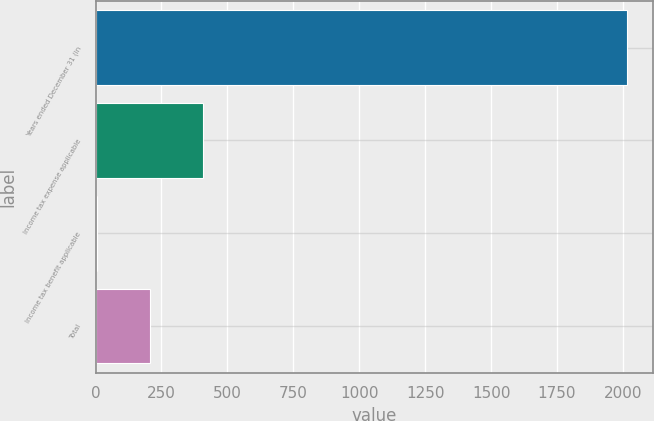<chart> <loc_0><loc_0><loc_500><loc_500><bar_chart><fcel>Years ended December 31 (in<fcel>Income tax expense applicable<fcel>Income tax benefit applicable<fcel>Total<nl><fcel>2014<fcel>408.16<fcel>6.7<fcel>207.43<nl></chart> 